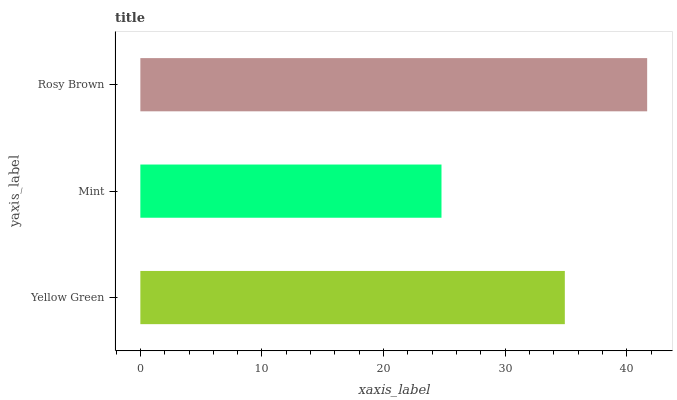Is Mint the minimum?
Answer yes or no. Yes. Is Rosy Brown the maximum?
Answer yes or no. Yes. Is Rosy Brown the minimum?
Answer yes or no. No. Is Mint the maximum?
Answer yes or no. No. Is Rosy Brown greater than Mint?
Answer yes or no. Yes. Is Mint less than Rosy Brown?
Answer yes or no. Yes. Is Mint greater than Rosy Brown?
Answer yes or no. No. Is Rosy Brown less than Mint?
Answer yes or no. No. Is Yellow Green the high median?
Answer yes or no. Yes. Is Yellow Green the low median?
Answer yes or no. Yes. Is Mint the high median?
Answer yes or no. No. Is Rosy Brown the low median?
Answer yes or no. No. 